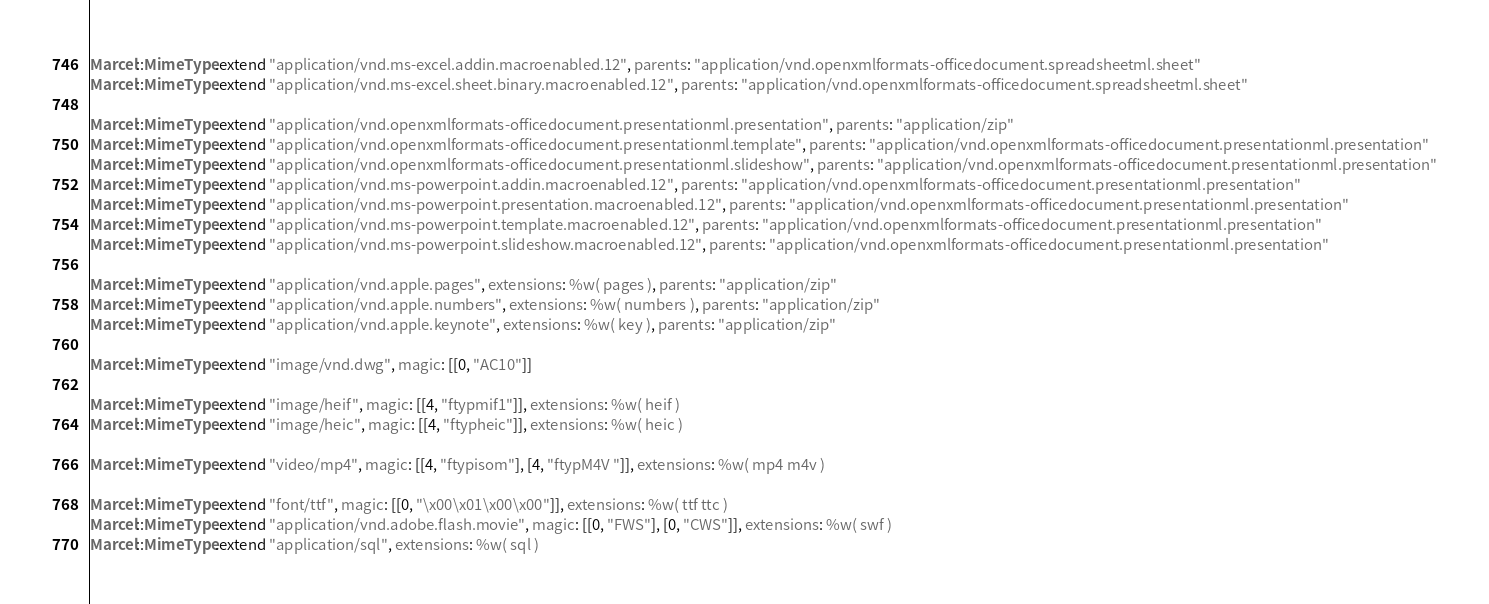<code> <loc_0><loc_0><loc_500><loc_500><_Ruby_>Marcel::MimeType.extend "application/vnd.ms-excel.addin.macroenabled.12", parents: "application/vnd.openxmlformats-officedocument.spreadsheetml.sheet"
Marcel::MimeType.extend "application/vnd.ms-excel.sheet.binary.macroenabled.12", parents: "application/vnd.openxmlformats-officedocument.spreadsheetml.sheet"

Marcel::MimeType.extend "application/vnd.openxmlformats-officedocument.presentationml.presentation", parents: "application/zip"
Marcel::MimeType.extend "application/vnd.openxmlformats-officedocument.presentationml.template", parents: "application/vnd.openxmlformats-officedocument.presentationml.presentation"
Marcel::MimeType.extend "application/vnd.openxmlformats-officedocument.presentationml.slideshow", parents: "application/vnd.openxmlformats-officedocument.presentationml.presentation"
Marcel::MimeType.extend "application/vnd.ms-powerpoint.addin.macroenabled.12", parents: "application/vnd.openxmlformats-officedocument.presentationml.presentation"
Marcel::MimeType.extend "application/vnd.ms-powerpoint.presentation.macroenabled.12", parents: "application/vnd.openxmlformats-officedocument.presentationml.presentation"
Marcel::MimeType.extend "application/vnd.ms-powerpoint.template.macroenabled.12", parents: "application/vnd.openxmlformats-officedocument.presentationml.presentation"
Marcel::MimeType.extend "application/vnd.ms-powerpoint.slideshow.macroenabled.12", parents: "application/vnd.openxmlformats-officedocument.presentationml.presentation"

Marcel::MimeType.extend "application/vnd.apple.pages", extensions: %w( pages ), parents: "application/zip"
Marcel::MimeType.extend "application/vnd.apple.numbers", extensions: %w( numbers ), parents: "application/zip"
Marcel::MimeType.extend "application/vnd.apple.keynote", extensions: %w( key ), parents: "application/zip"

Marcel::MimeType.extend "image/vnd.dwg", magic: [[0, "AC10"]]

Marcel::MimeType.extend "image/heif", magic: [[4, "ftypmif1"]], extensions: %w( heif )
Marcel::MimeType.extend "image/heic", magic: [[4, "ftypheic"]], extensions: %w( heic )

Marcel::MimeType.extend "video/mp4", magic: [[4, "ftypisom"], [4, "ftypM4V "]], extensions: %w( mp4 m4v )

Marcel::MimeType.extend "font/ttf", magic: [[0, "\x00\x01\x00\x00"]], extensions: %w( ttf ttc )
Marcel::MimeType.extend "application/vnd.adobe.flash.movie", magic: [[0, "FWS"], [0, "CWS"]], extensions: %w( swf )
Marcel::MimeType.extend "application/sql", extensions: %w( sql )
</code> 